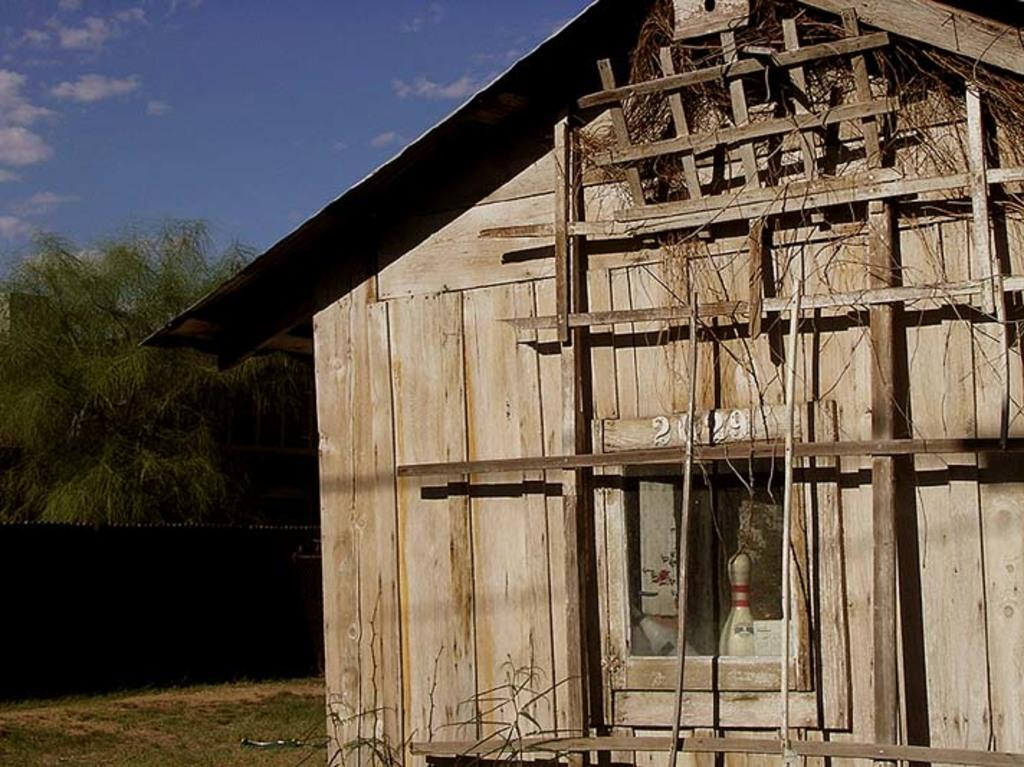What type of house is in the picture? There is a wooden house in the picture. What other natural elements can be seen in the picture? There are trees in the picture. What kind of barrier is present in the picture? There is a fence in the picture. What else can be seen in the picture besides the house, trees, and fence? There are other objects in the picture. What is visible in the background of the picture? The sky is visible in the background of the picture. What type of power source is visible in the picture? There is no power source visible in the picture; it only features a wooden house, trees, a fence, other objects, and the sky in the background. 